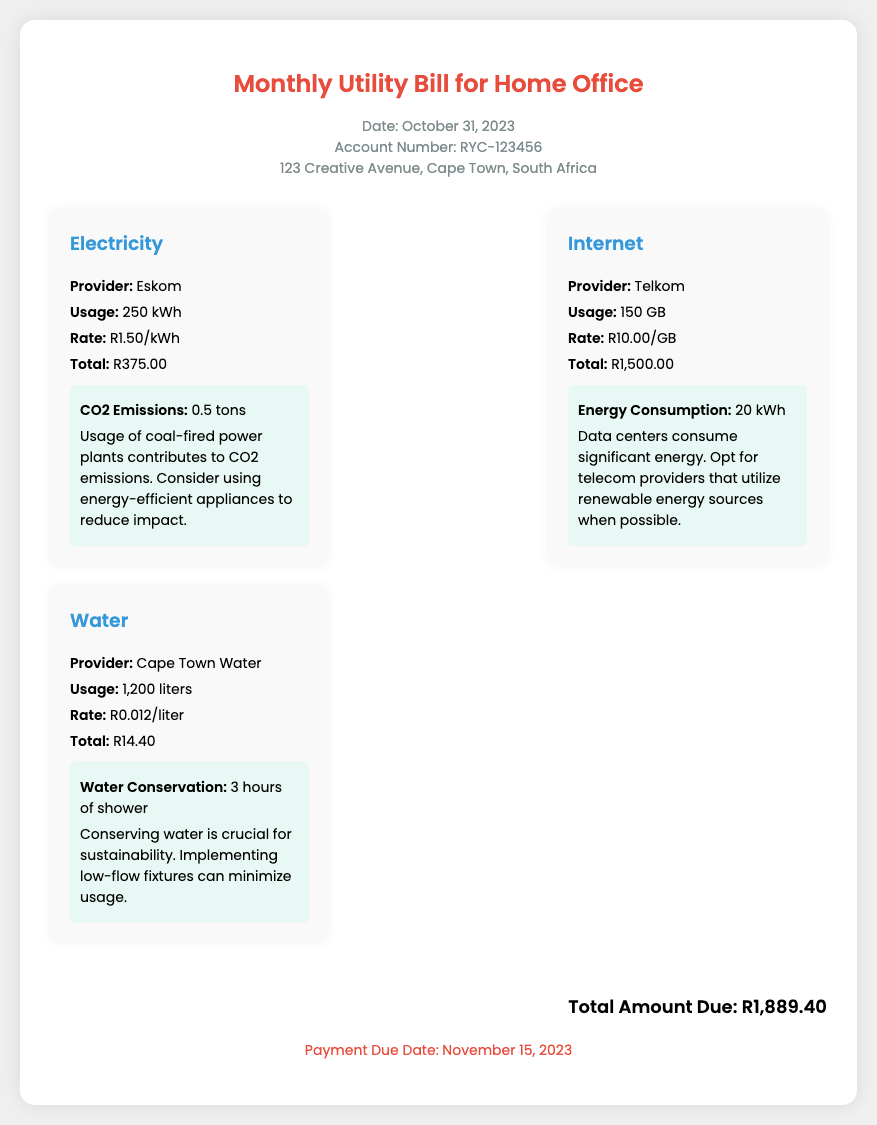What is the total due amount? The total due amount is presented at the bottom of the document, calculated based on the individual utility totals.
Answer: R1,889.40 What is the usage in electricity? The electricity usage is specifically mentioned under the Electricity utility card in the document.
Answer: 250 kWh What is the provider for internet service? The internet provider is listed in the Internet utility card in the document.
Answer: Telkom When is the payment due date? The payment due date is clearly stated at the bottom of the document.
Answer: November 15, 2023 What is the CO2 emissions for electricity? The CO2 emissions for electricity usage is mentioned in the environmental impact section of the Electricity utility card.
Answer: 0.5 tons What is the rate per liter for water? The rate for water usage is found in the Water utility card in the document.
Answer: R0.012/liter How much was spent on internet? The total amount spent on internet usage is indicated in the Internet utility card.
Answer: R1,500.00 What is the energy consumption for internet? The energy consumption related to internet usage is provided in the environmental impact section of the Internet utility card.
Answer: 20 kWh 